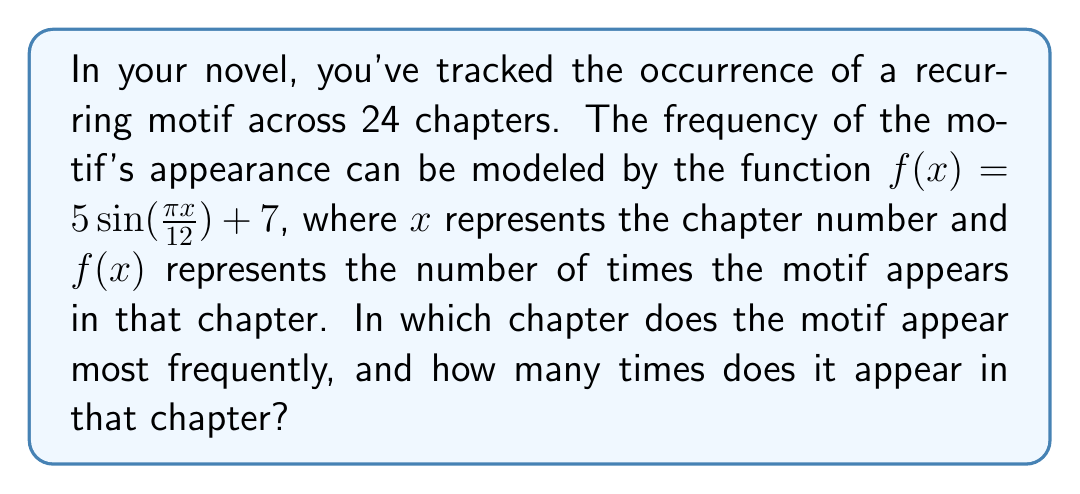Teach me how to tackle this problem. To solve this problem, we need to follow these steps:

1) The sine function reaches its maximum value when its argument is $\frac{\pi}{2} + 2\pi n$, where $n$ is any integer. In this case, we need to solve:

   $$\frac{\pi x}{12} = \frac{\pi}{2} + 2\pi n$$

2) Simplifying:

   $$x = 6 + 24n$$

3) Since we have 24 chapters, the maximum will occur when $n = 0$, giving us $x = 6$. This means the motif appears most frequently in Chapter 6.

4) To find how many times it appears in this chapter, we substitute $x = 6$ into our original function:

   $$f(6) = 5 \sin(\frac{\pi \cdot 6}{12}) + 7$$

5) Simplifying:

   $$f(6) = 5 \sin(\frac{\pi}{2}) + 7 = 5 \cdot 1 + 7 = 12$$

Therefore, the motif appears 12 times in Chapter 6, which is the maximum frequency.
Answer: Chapter 6; 12 times 